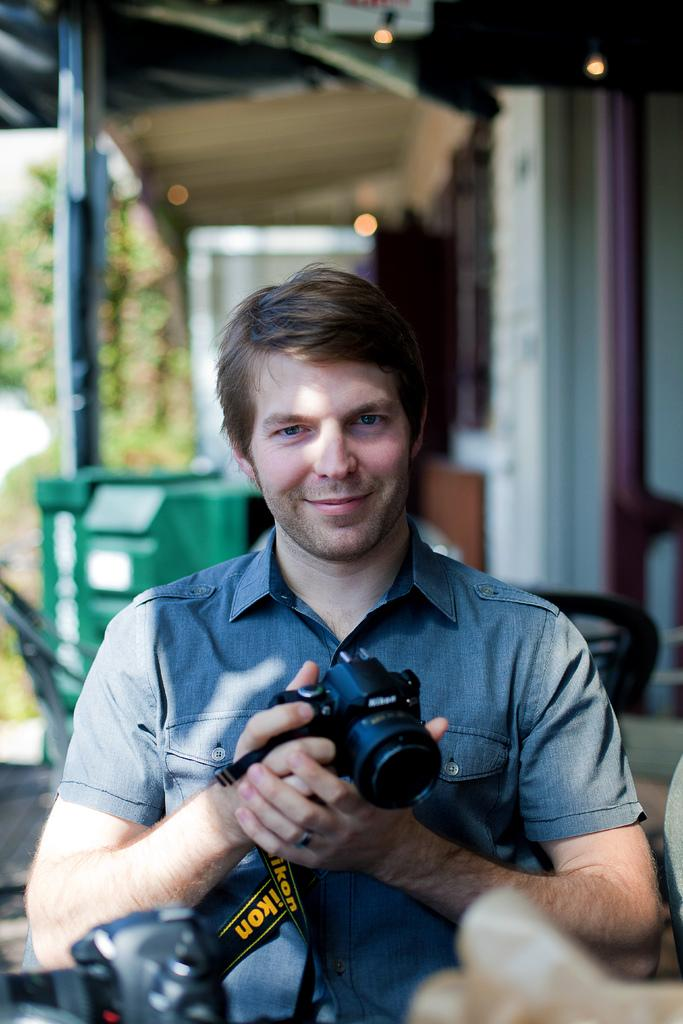What is the person in the image doing? The person is sitting in the image. What expression does the person have? The person is smiling. What is the person holding in the image? The person is holding a Nikon camera in both hands. What can be seen in the background of the image? There is a pole, trees, and a door in the background of the image. What type of texture can be seen on the person's head in the image? There is no information about the texture of the person's head in the image, as it is not mentioned in the provided facts. 